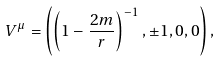Convert formula to latex. <formula><loc_0><loc_0><loc_500><loc_500>V ^ { \mu } = \left ( \left ( 1 - \frac { 2 m } r \right ) ^ { - 1 } , \pm 1 , 0 , 0 \right ) ,</formula> 